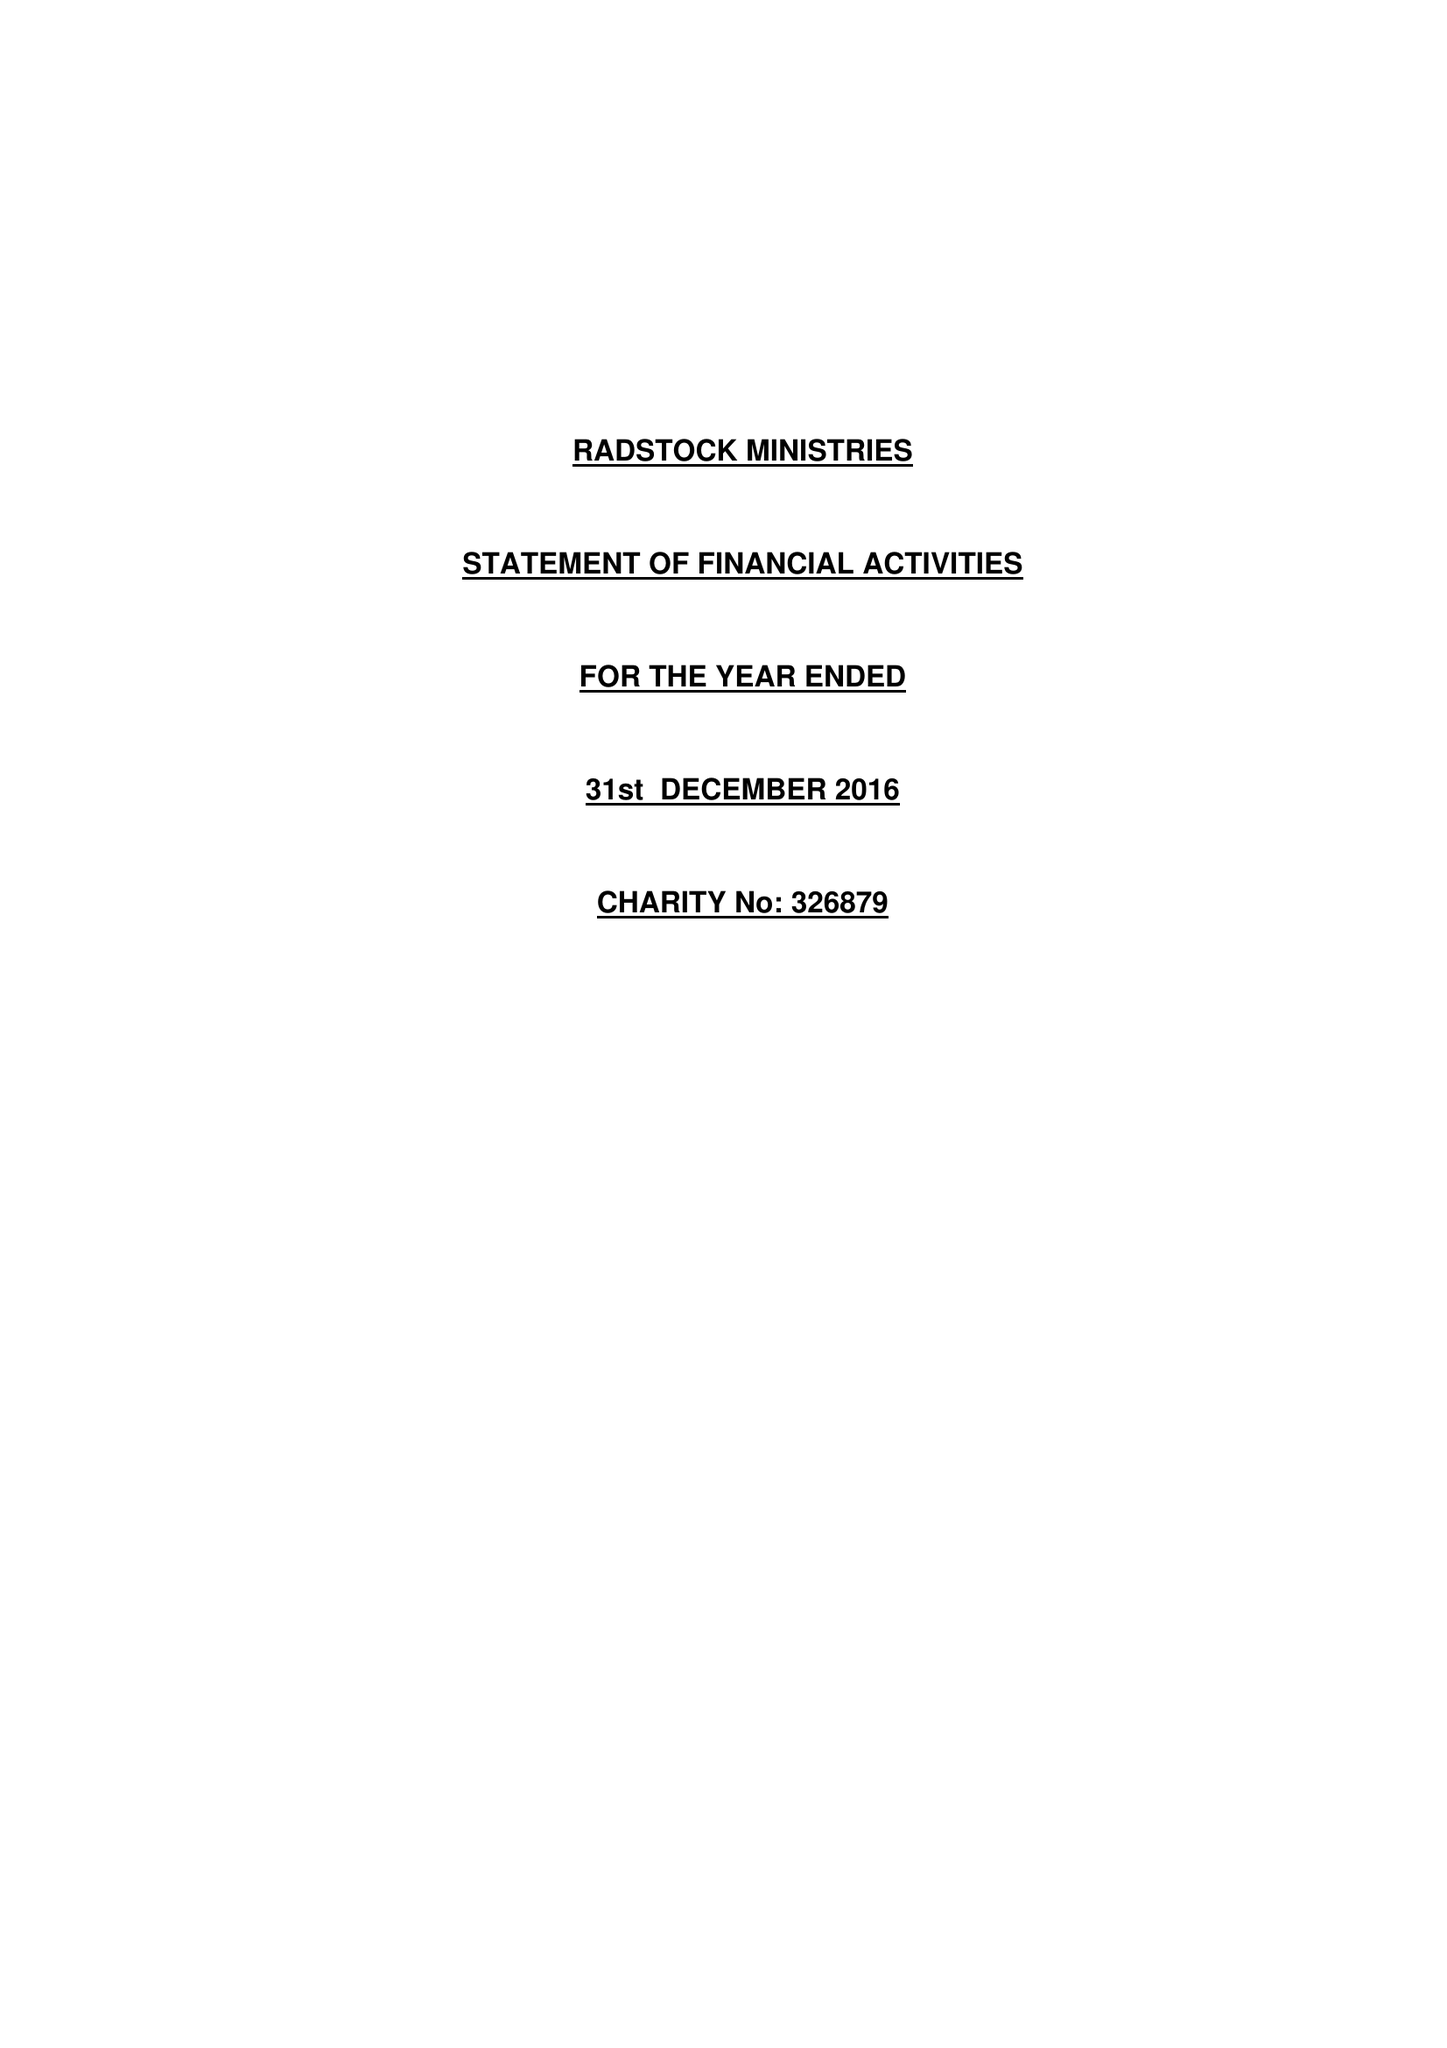What is the value for the charity_name?
Answer the question using a single word or phrase. Radstock Ministries 